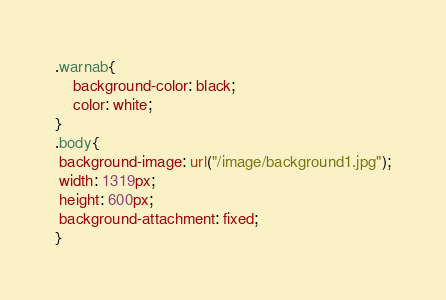<code> <loc_0><loc_0><loc_500><loc_500><_CSS_>.warnab{
	background-color: black;
	color: white;
}
.body{
 background-image: url("/image/background1.jpg");
 width: 1319px;
 height: 600px; 	
 background-attachment: fixed;
}
</code> 